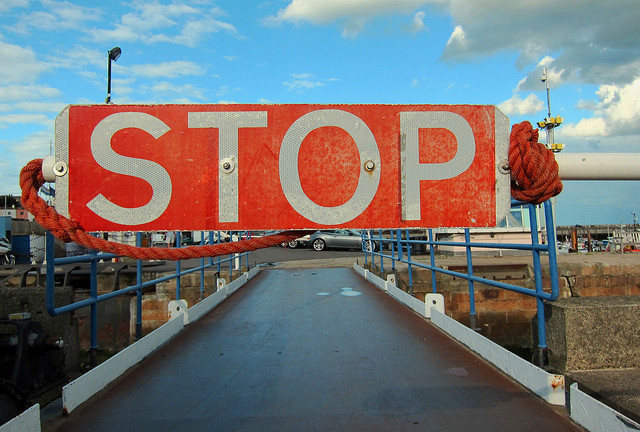What purpose does the stop sign serve in this location? The stop sign likely serves to regulate traffic or pedestrian access to the bridge or dock, ensuring safety and controlling the flow of people or vehicles.  Is there anything unusual or out of the ordinary in this image? The scene is quite standard for a dock or port area. However, the large stop sign erected directly on the pathway is somewhat unusual, as it completely blocks access, which may indicate construction, a private event, or temporary closure. 